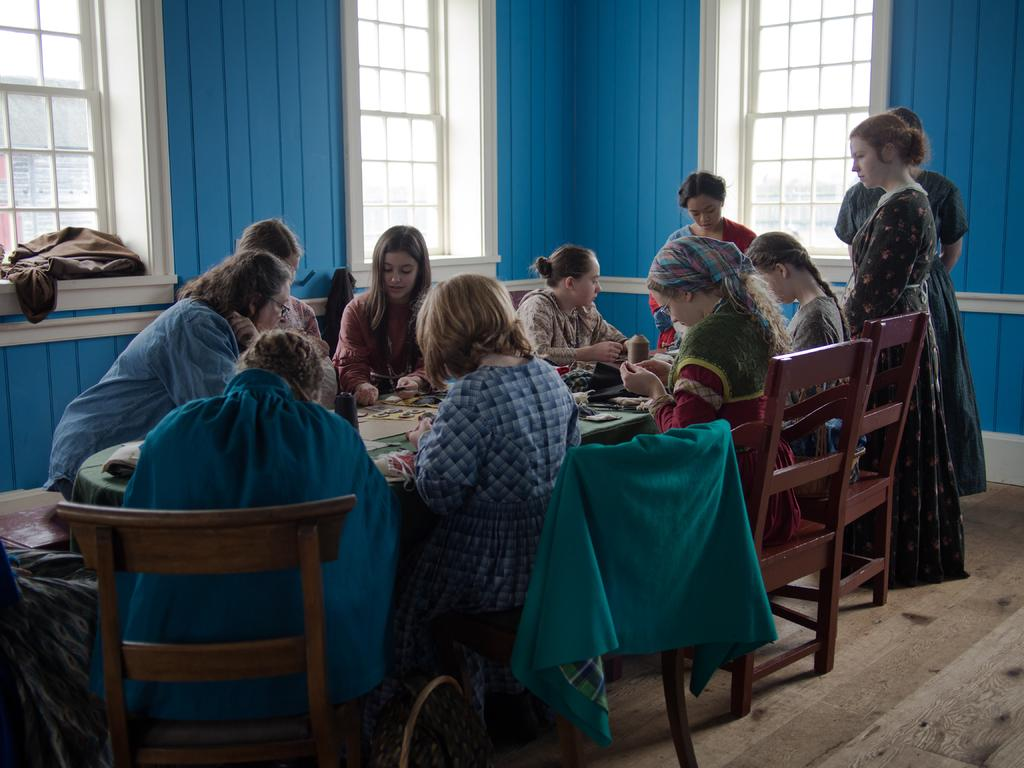What are the people in the image doing? The persons in the image are sitting on chairs. What is present in the image besides the people? There is a table in the image. What is on the table? There are papers on the table. What can be seen in the background of the image? There are windows made of glass in the background. What type of holiday is being celebrated in the image? There is no indication of a holiday being celebrated in the image. Can you see any cracks in the windows made of glass in the background? There are no cracks visible in the windows made of glass in the background. 